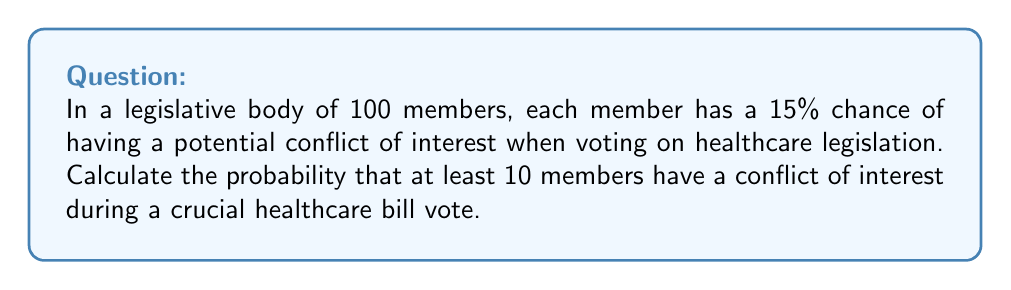Give your solution to this math problem. To solve this problem, we'll use the binomial distribution and its complementary event. Let's break it down step-by-step:

1) Let X be the random variable representing the number of members with a conflict of interest.

2) X follows a binomial distribution with n = 100 (total members) and p = 0.15 (probability of conflict for each member).

3) We need to find P(X ≥ 10), which is equivalent to 1 - P(X < 10) or 1 - P(X ≤ 9).

4) The probability mass function for a binomial distribution is:

   $$P(X = k) = \binom{n}{k} p^k (1-p)^{n-k}$$

5) We need to sum this for k = 0 to 9:

   $$P(X \leq 9) = \sum_{k=0}^9 \binom{100}{k} (0.15)^k (0.85)^{100-k}$$

6) This sum is computationally intensive, so we'll use the cumulative distribution function of the binomial distribution, which can be approximated using the normal distribution when np > 5 and n(1-p) > 5. In this case:

   np = 100 * 0.15 = 15 > 5
   n(1-p) = 100 * 0.85 = 85 > 5

7) We can use the normal approximation with:
   
   $$\mu = np = 100 * 0.15 = 15$$
   $$\sigma = \sqrt{np(1-p)} = \sqrt{100 * 0.15 * 0.85} \approx 3.5746$$

8) We need to apply a continuity correction, so we calculate:

   $$P(X \leq 9) \approx P(Z \leq \frac{9.5 - 15}{3.5746})$$

   where Z is a standard normal random variable.

9) This gives us:

   $$P(X \leq 9) \approx P(Z \leq -1.5386)$$

10) Using a standard normal table or calculator, we find:

    $$P(Z \leq -1.5386) \approx 0.0620$$

11) Therefore, P(X ≥ 10) = 1 - P(X ≤ 9) ≈ 1 - 0.0620 = 0.9380
Answer: The probability that at least 10 members have a conflict of interest is approximately 0.9380 or 93.80%. 